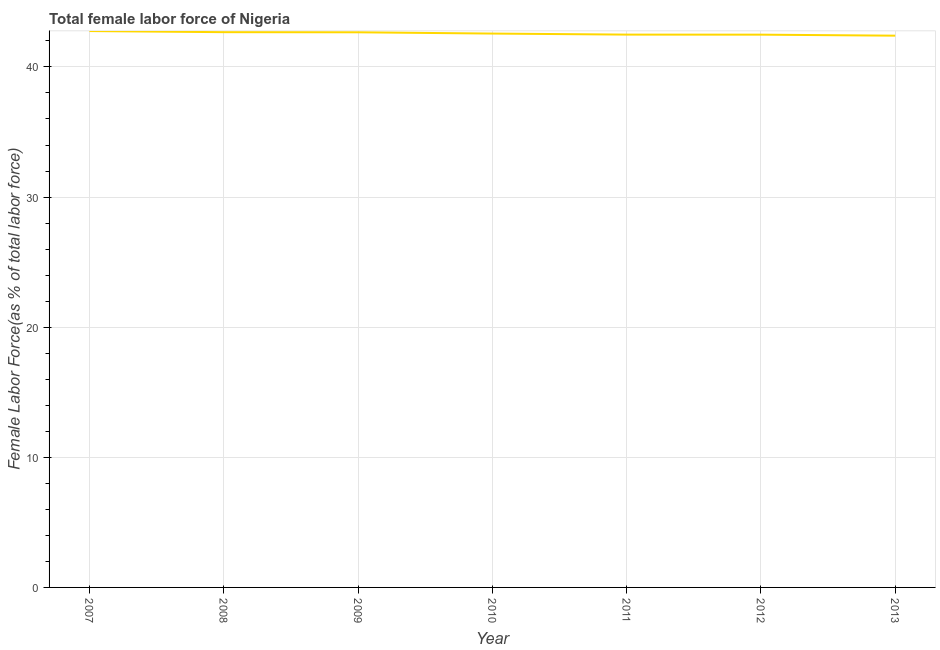What is the total female labor force in 2010?
Provide a short and direct response. 42.57. Across all years, what is the maximum total female labor force?
Give a very brief answer. 42.76. Across all years, what is the minimum total female labor force?
Make the answer very short. 42.4. In which year was the total female labor force minimum?
Offer a very short reply. 2013. What is the sum of the total female labor force?
Offer a very short reply. 298.03. What is the difference between the total female labor force in 2007 and 2013?
Provide a succinct answer. 0.36. What is the average total female labor force per year?
Offer a terse response. 42.58. What is the median total female labor force?
Your answer should be very brief. 42.57. In how many years, is the total female labor force greater than 30 %?
Offer a terse response. 7. What is the ratio of the total female labor force in 2008 to that in 2010?
Provide a succinct answer. 1. Is the difference between the total female labor force in 2010 and 2012 greater than the difference between any two years?
Provide a succinct answer. No. What is the difference between the highest and the second highest total female labor force?
Make the answer very short. 0.09. Is the sum of the total female labor force in 2012 and 2013 greater than the maximum total female labor force across all years?
Keep it short and to the point. Yes. What is the difference between the highest and the lowest total female labor force?
Give a very brief answer. 0.36. In how many years, is the total female labor force greater than the average total female labor force taken over all years?
Provide a succinct answer. 3. How many lines are there?
Make the answer very short. 1. How many years are there in the graph?
Ensure brevity in your answer.  7. What is the difference between two consecutive major ticks on the Y-axis?
Your answer should be compact. 10. Are the values on the major ticks of Y-axis written in scientific E-notation?
Provide a succinct answer. No. Does the graph contain any zero values?
Make the answer very short. No. Does the graph contain grids?
Make the answer very short. Yes. What is the title of the graph?
Give a very brief answer. Total female labor force of Nigeria. What is the label or title of the Y-axis?
Ensure brevity in your answer.  Female Labor Force(as % of total labor force). What is the Female Labor Force(as % of total labor force) of 2007?
Your response must be concise. 42.76. What is the Female Labor Force(as % of total labor force) in 2008?
Your answer should be compact. 42.67. What is the Female Labor Force(as % of total labor force) of 2009?
Keep it short and to the point. 42.66. What is the Female Labor Force(as % of total labor force) in 2010?
Offer a terse response. 42.57. What is the Female Labor Force(as % of total labor force) of 2011?
Give a very brief answer. 42.49. What is the Female Labor Force(as % of total labor force) in 2012?
Provide a short and direct response. 42.48. What is the Female Labor Force(as % of total labor force) in 2013?
Make the answer very short. 42.4. What is the difference between the Female Labor Force(as % of total labor force) in 2007 and 2008?
Your answer should be very brief. 0.09. What is the difference between the Female Labor Force(as % of total labor force) in 2007 and 2009?
Keep it short and to the point. 0.1. What is the difference between the Female Labor Force(as % of total labor force) in 2007 and 2010?
Give a very brief answer. 0.19. What is the difference between the Female Labor Force(as % of total labor force) in 2007 and 2011?
Your answer should be compact. 0.27. What is the difference between the Female Labor Force(as % of total labor force) in 2007 and 2012?
Offer a very short reply. 0.28. What is the difference between the Female Labor Force(as % of total labor force) in 2007 and 2013?
Your answer should be very brief. 0.36. What is the difference between the Female Labor Force(as % of total labor force) in 2008 and 2009?
Make the answer very short. 0.01. What is the difference between the Female Labor Force(as % of total labor force) in 2008 and 2010?
Make the answer very short. 0.11. What is the difference between the Female Labor Force(as % of total labor force) in 2008 and 2011?
Ensure brevity in your answer.  0.19. What is the difference between the Female Labor Force(as % of total labor force) in 2008 and 2012?
Give a very brief answer. 0.19. What is the difference between the Female Labor Force(as % of total labor force) in 2008 and 2013?
Provide a short and direct response. 0.27. What is the difference between the Female Labor Force(as % of total labor force) in 2009 and 2010?
Offer a very short reply. 0.1. What is the difference between the Female Labor Force(as % of total labor force) in 2009 and 2011?
Offer a terse response. 0.18. What is the difference between the Female Labor Force(as % of total labor force) in 2009 and 2012?
Ensure brevity in your answer.  0.18. What is the difference between the Female Labor Force(as % of total labor force) in 2009 and 2013?
Keep it short and to the point. 0.26. What is the difference between the Female Labor Force(as % of total labor force) in 2010 and 2011?
Your answer should be very brief. 0.08. What is the difference between the Female Labor Force(as % of total labor force) in 2010 and 2012?
Give a very brief answer. 0.08. What is the difference between the Female Labor Force(as % of total labor force) in 2010 and 2013?
Keep it short and to the point. 0.16. What is the difference between the Female Labor Force(as % of total labor force) in 2011 and 2012?
Your response must be concise. 0. What is the difference between the Female Labor Force(as % of total labor force) in 2011 and 2013?
Give a very brief answer. 0.08. What is the difference between the Female Labor Force(as % of total labor force) in 2012 and 2013?
Make the answer very short. 0.08. What is the ratio of the Female Labor Force(as % of total labor force) in 2007 to that in 2009?
Provide a short and direct response. 1. What is the ratio of the Female Labor Force(as % of total labor force) in 2007 to that in 2012?
Make the answer very short. 1.01. What is the ratio of the Female Labor Force(as % of total labor force) in 2008 to that in 2011?
Offer a terse response. 1. What is the ratio of the Female Labor Force(as % of total labor force) in 2008 to that in 2013?
Ensure brevity in your answer.  1.01. What is the ratio of the Female Labor Force(as % of total labor force) in 2009 to that in 2010?
Keep it short and to the point. 1. What is the ratio of the Female Labor Force(as % of total labor force) in 2009 to that in 2011?
Make the answer very short. 1. What is the ratio of the Female Labor Force(as % of total labor force) in 2009 to that in 2013?
Provide a short and direct response. 1.01. What is the ratio of the Female Labor Force(as % of total labor force) in 2012 to that in 2013?
Your response must be concise. 1. 